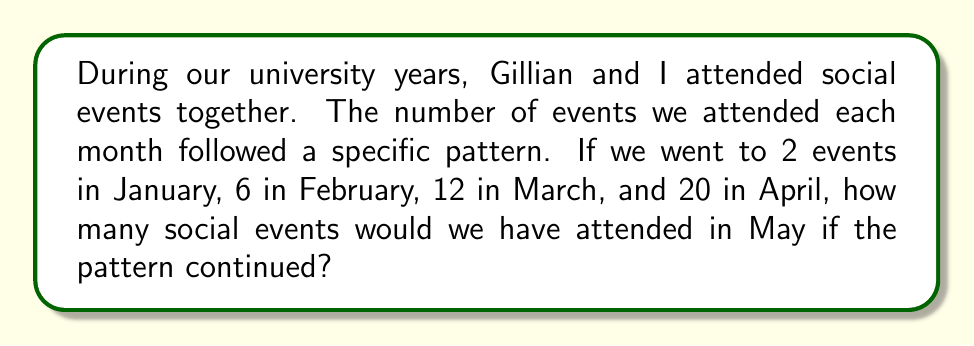Help me with this question. Let's analyze the sequence of social events:

January: 2
February: 6
March: 12
April: 20

To find the rule, we need to look at the differences between consecutive terms:

1. From January to February: $6 - 2 = 4$
2. From February to March: $12 - 6 = 6$
3. From March to April: $20 - 12 = 8$

We can see that the differences are increasing by 2 each time: 4, 6, 8.

This suggests that the sequence follows the pattern of a quadratic function, specifically an arithmetic sequence of second order.

The general formula for such a sequence is:

$$ a_n = an^2 + bn + c $$

Where $n$ is the term number (January = 1, February = 2, etc.), and $a$, $b$, and $c$ are constants we need to determine.

Given the first term (January, $n=1$) is 2, we can write:

$$ 2 = a(1)^2 + b(1) + c $$

Simplifying:

$$ 2 = a + b + c \quad (1) $$

Now, let's use the second term (February, $n=2$):

$$ 6 = a(2)^2 + b(2) + c $$
$$ 6 = 4a + 2b + c \quad (2) $$

And the third term (March, $n=3$):

$$ 12 = a(3)^2 + b(3) + c $$
$$ 12 = 9a + 3b + c \quad (3) $$

Subtracting equation (1) from (2):
$$ 4 = 3a + b \quad (4) $$

Subtracting equation (2) from (3):
$$ 6 = 5a + b \quad (5) $$

Subtracting equation (4) from (5):
$$ 2 = 2a $$
$$ a = 1 $$

Substituting this back into equation (4):
$$ 4 = 3(1) + b $$
$$ b = 1 $$

And finally, using these values in equation (1):
$$ 2 = 1 + 1 + c $$
$$ c = 0 $$

Therefore, our sequence follows the rule:

$$ a_n = n^2 + n $$

For May, which would be the 5th term ($n=5$):

$$ a_5 = 5^2 + 5 = 25 + 5 = 30 $$

Thus, in May, Gillian and I would have attended 30 social events if the pattern continued.
Answer: 30 events 